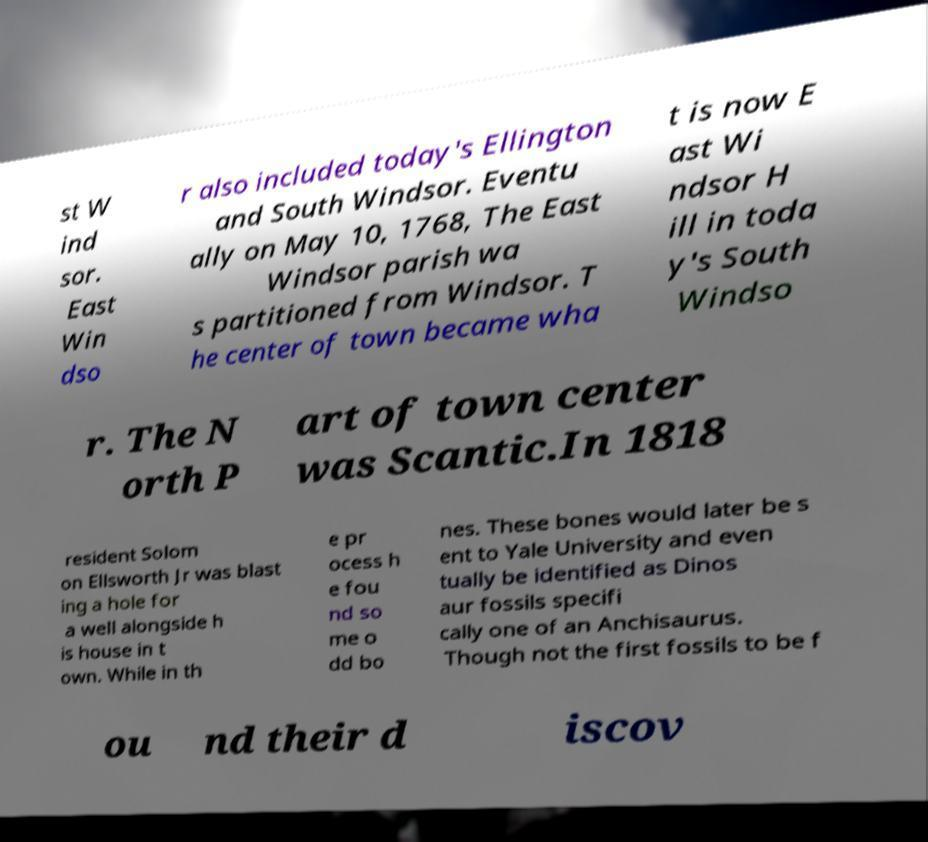There's text embedded in this image that I need extracted. Can you transcribe it verbatim? st W ind sor. East Win dso r also included today's Ellington and South Windsor. Eventu ally on May 10, 1768, The East Windsor parish wa s partitioned from Windsor. T he center of town became wha t is now E ast Wi ndsor H ill in toda y's South Windso r. The N orth P art of town center was Scantic.In 1818 resident Solom on Ellsworth Jr was blast ing a hole for a well alongside h is house in t own. While in th e pr ocess h e fou nd so me o dd bo nes. These bones would later be s ent to Yale University and even tually be identified as Dinos aur fossils specifi cally one of an Anchisaurus. Though not the first fossils to be f ou nd their d iscov 